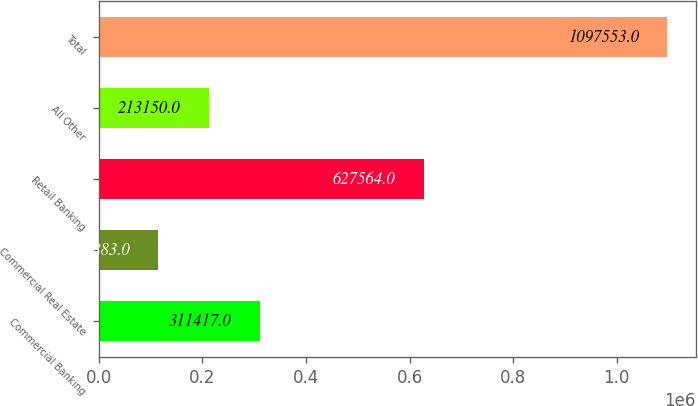Convert chart to OTSL. <chart><loc_0><loc_0><loc_500><loc_500><bar_chart><fcel>Commercial Banking<fcel>Commercial Real Estate<fcel>Retail Banking<fcel>All Other<fcel>Total<nl><fcel>311417<fcel>114883<fcel>627564<fcel>213150<fcel>1.09755e+06<nl></chart> 